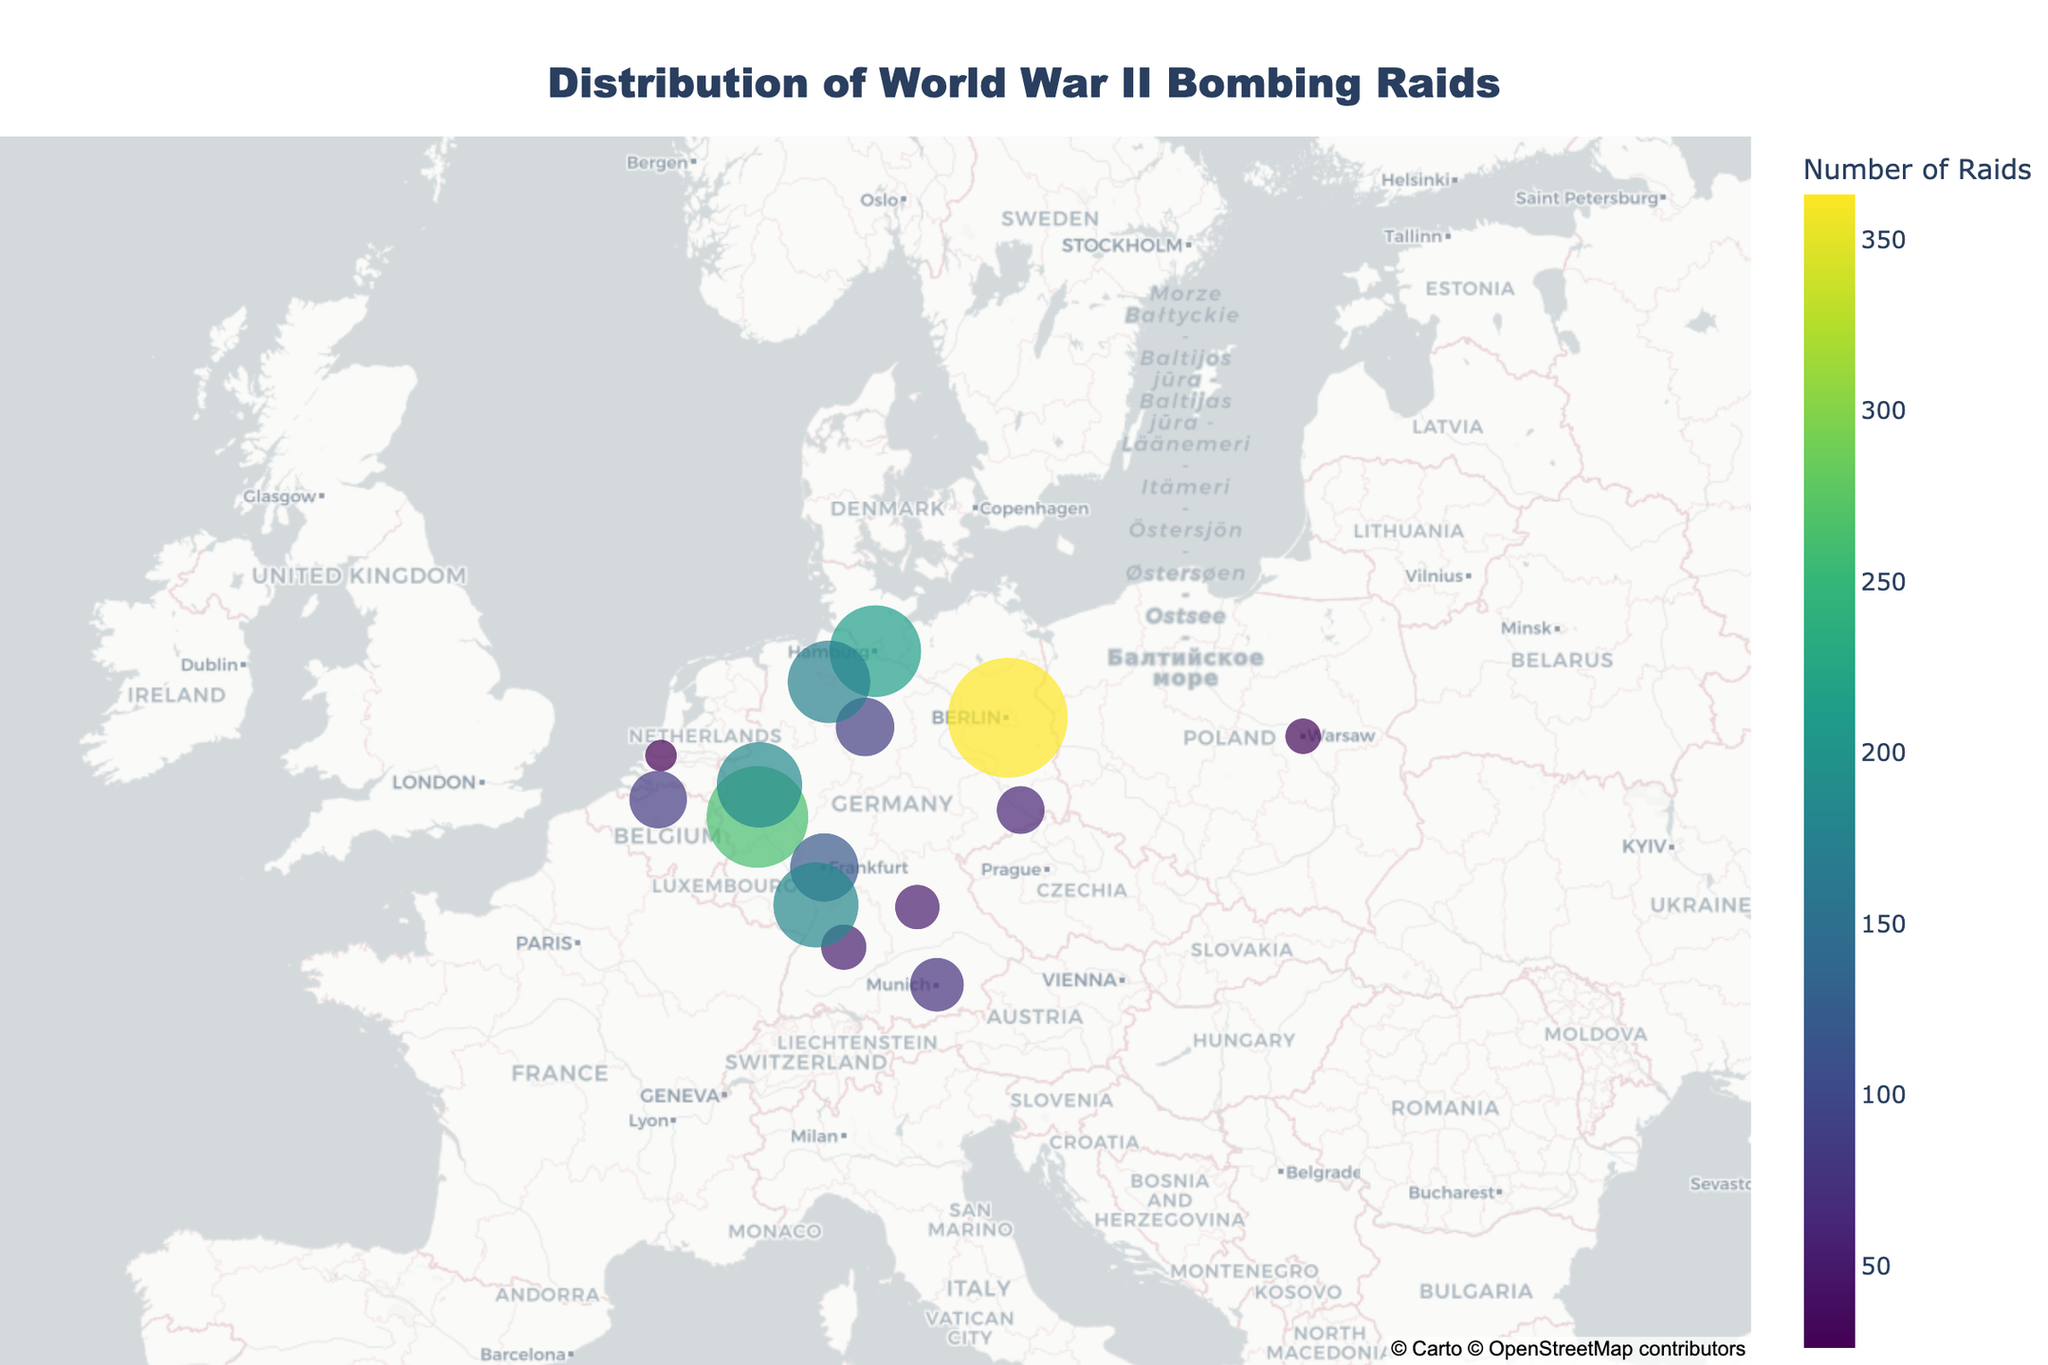What is the title of the plot? The title of the plot can be located at the top and is generally designed to provide a concise summary of the visualized data.
Answer: Distribution of World War II Bombing Raids Which city had the highest number of bombing raids? Identify the city with the largest bubble or highest numeric value in the annotations on the plot.
Answer: Berlin How many bombing raids did Hamburg experience? Hover over the city Hamburg on the plot to reveal detailed information, including the number of raids.
Answer: 213 Which three cities had the lowest number of bombing raids? Look for the smallest bubbles or the annotations with the lowest values on the plot, then identify the corresponding city names.
Answer: Rotterdam, Warsaw, Dresden What is the total number of bombing raids recorded for all cities shown? Sum up all the raid values provided in the annotations for each city: (363 + 213 + 262 + 59 + 74 + 119 + 185 + 26 + 85 + 33 + 51 + 53 + 184 + 88 + 173).
Answer: 1967 Which German city had the fewest bombing raids? Look for the smallest bubble among the German cities or the annotation with the smallest value and identify the city.
Answer: Dresden How does the number of raids in Cologne compare to the number in Frankfurt? Check the values for Cologne and Frankfurt, then determine which is greater or if they are equal.
Answer: Cologne had more raids than Frankfurt (262 > 119) What is the median number of bombing raids among all the cities listed? Arrange the radii in ascending order and find the middle value. The ordered list is: 26, 33, 51, 53, 59, 74, 85, 88, 119, 173, 184, 185, 213, 262, 363. The median is the 8th value in this ordered list.
Answer: 88 How many German cities are included in the plot? Count the number of cities located in Germany from the plot's annotations or the dataset provided.
Answer: 11 